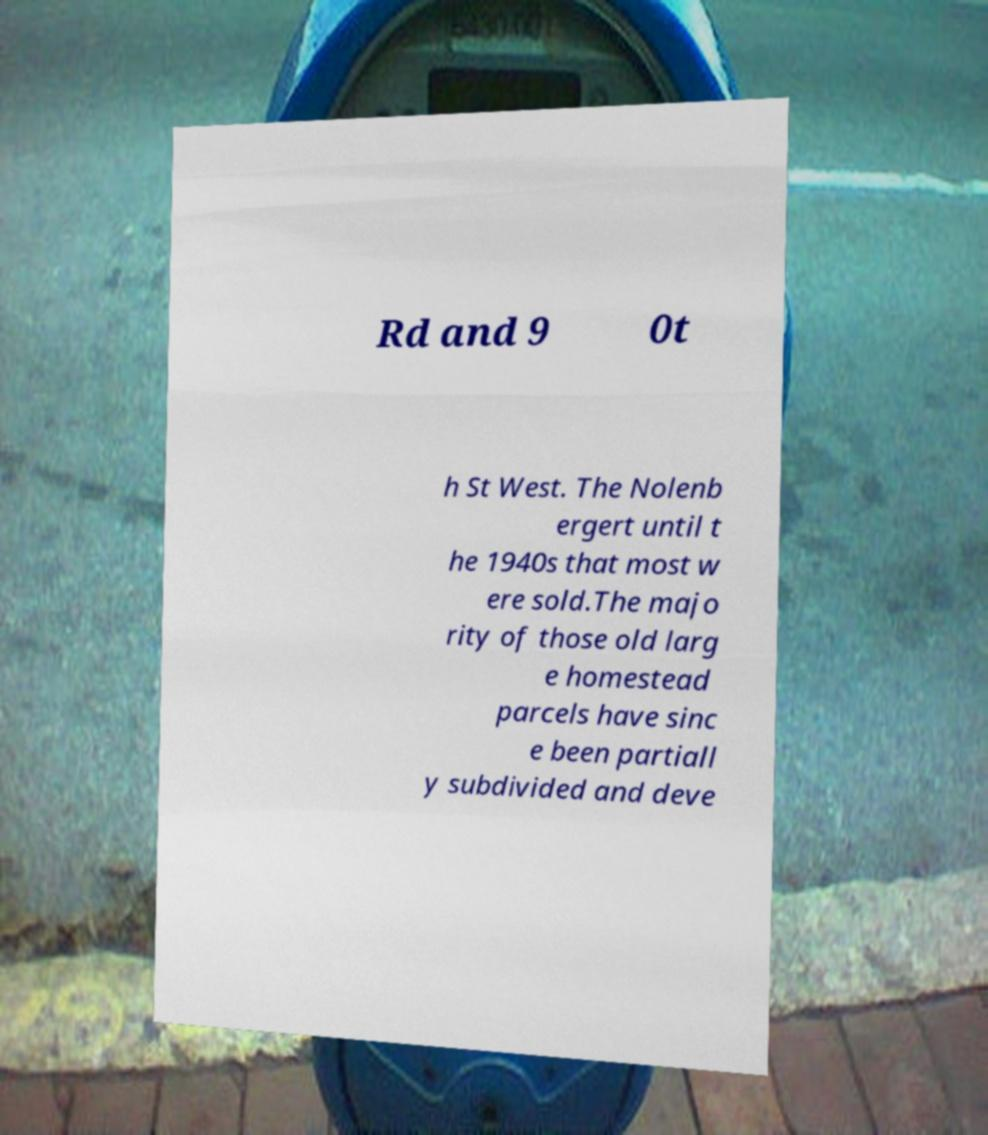For documentation purposes, I need the text within this image transcribed. Could you provide that? Rd and 9 0t h St West. The Nolenb ergert until t he 1940s that most w ere sold.The majo rity of those old larg e homestead parcels have sinc e been partiall y subdivided and deve 